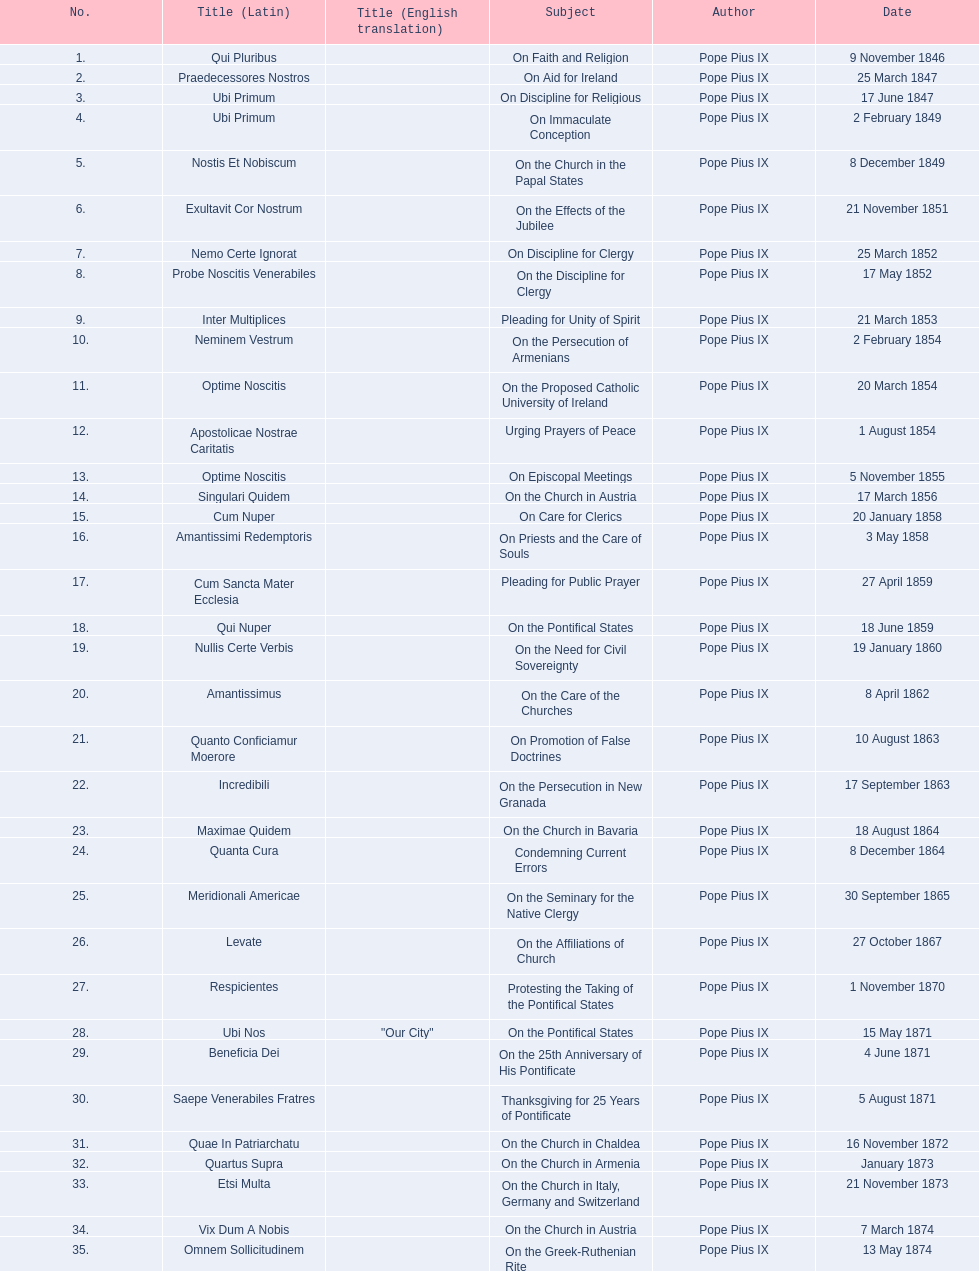How many encyclicals were issued between august 15, 1854 and october 26, 1867? 13. 